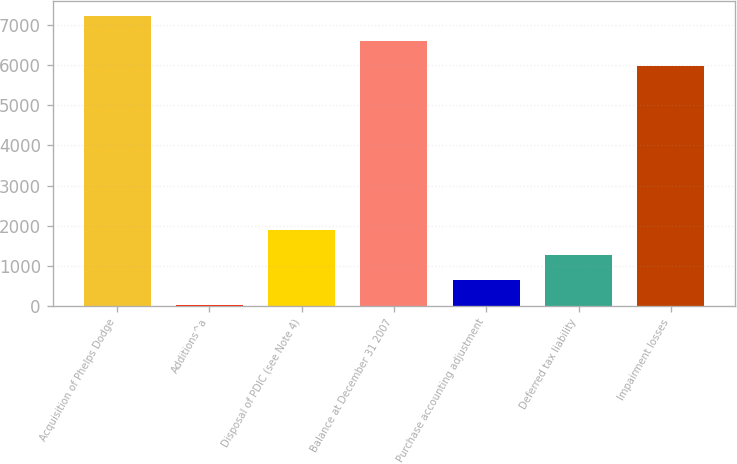Convert chart. <chart><loc_0><loc_0><loc_500><loc_500><bar_chart><fcel>Acquisition of Phelps Dodge<fcel>Additions^a<fcel>Disposal of PDIC (see Note 4)<fcel>Balance at December 31 2007<fcel>Purchase accounting adjustment<fcel>Deferred tax liability<fcel>Impairment losses<nl><fcel>7235.8<fcel>21<fcel>1894.2<fcel>6611.4<fcel>645.4<fcel>1269.8<fcel>5987<nl></chart> 